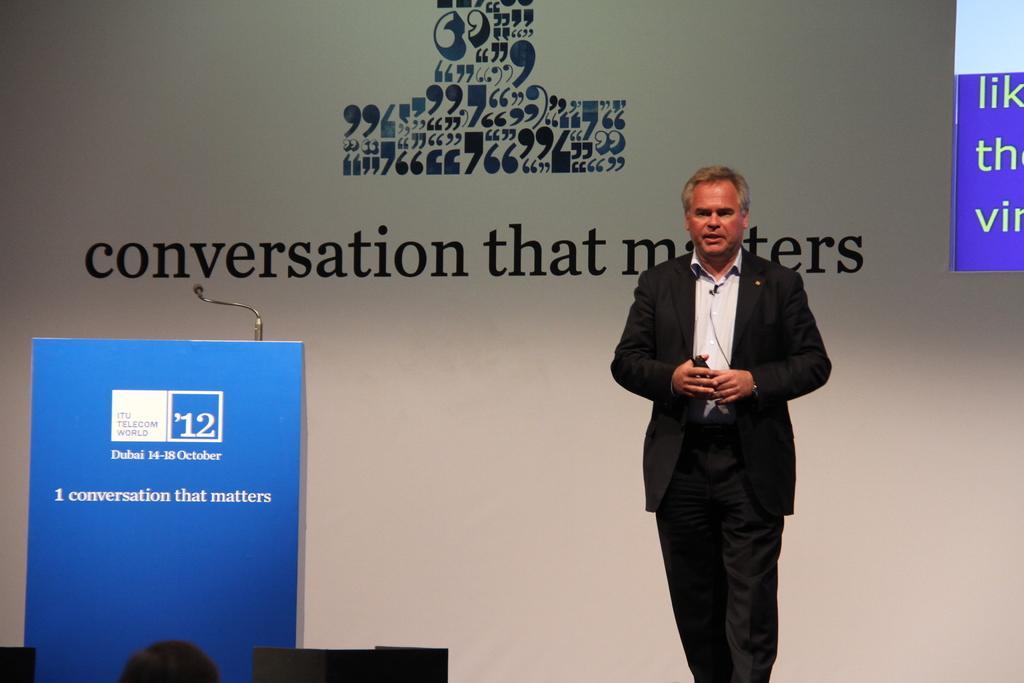Please provide a concise description of this image. In this picture we can see a person standing and holding a mic in his hand. We can see a podium and a mic on the left side. We can see a person. There is a poster in the background. 